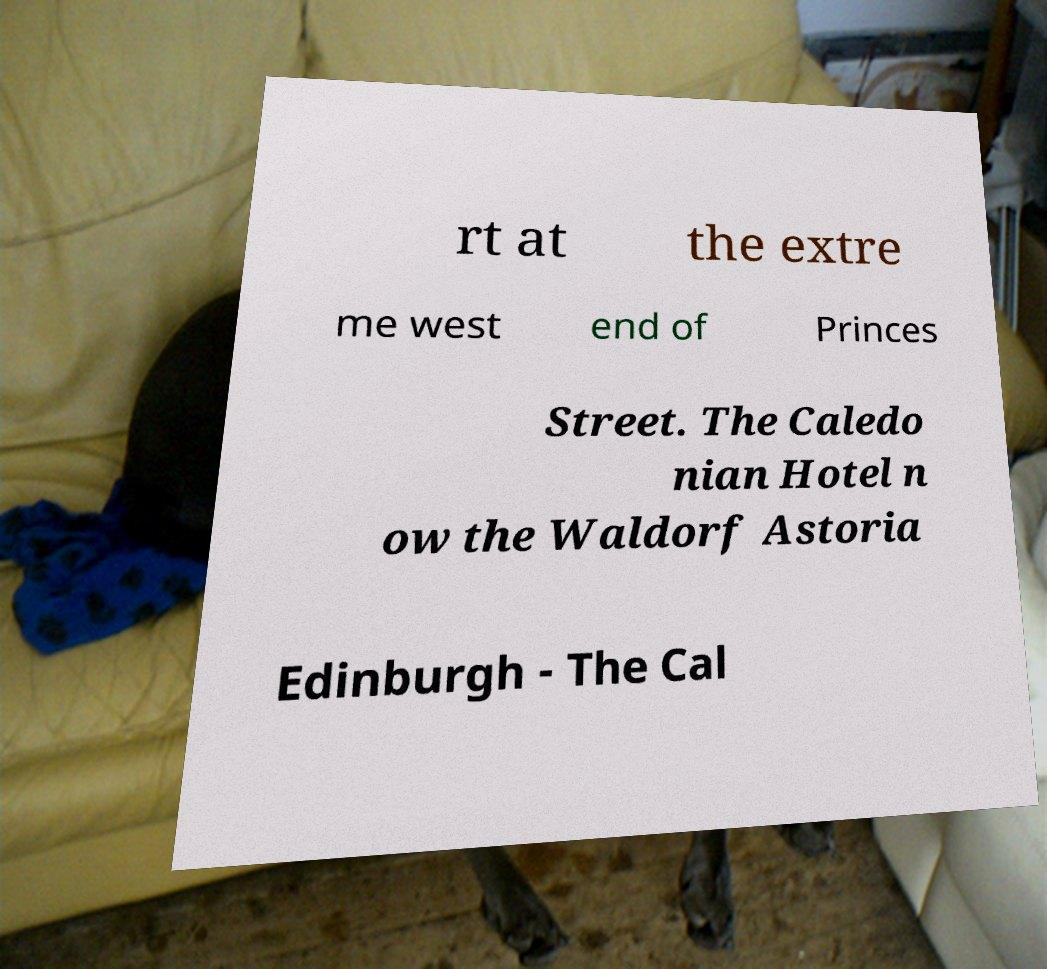Could you extract and type out the text from this image? rt at the extre me west end of Princes Street. The Caledo nian Hotel n ow the Waldorf Astoria Edinburgh - The Cal 